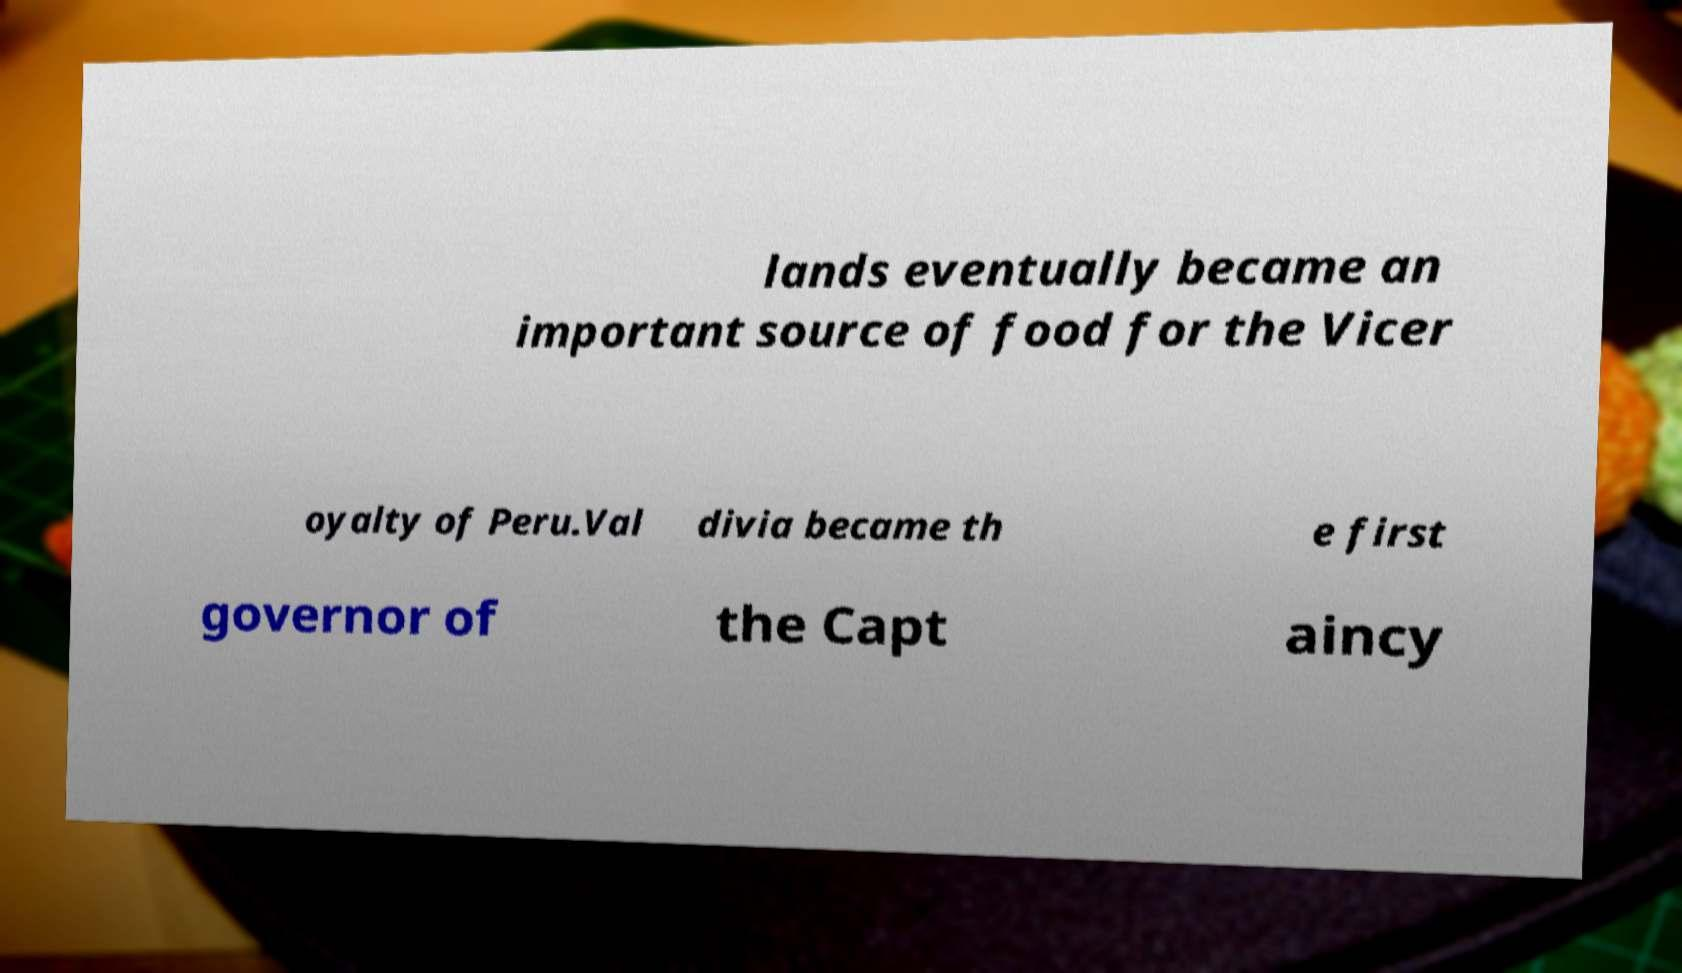Can you read and provide the text displayed in the image?This photo seems to have some interesting text. Can you extract and type it out for me? lands eventually became an important source of food for the Vicer oyalty of Peru.Val divia became th e first governor of the Capt aincy 